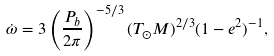<formula> <loc_0><loc_0><loc_500><loc_500>\dot { \omega } = 3 \left ( \frac { P _ { b } } { 2 \pi } \right ) ^ { - 5 / 3 } ( T _ { \odot } M ) ^ { 2 / 3 } ( 1 - e ^ { 2 } ) ^ { - 1 } ,</formula> 